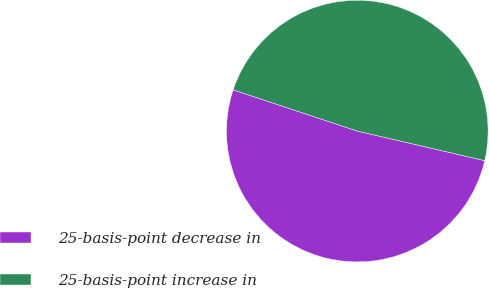<chart> <loc_0><loc_0><loc_500><loc_500><pie_chart><fcel>25-basis-point decrease in<fcel>25-basis-point increase in<nl><fcel>51.47%<fcel>48.53%<nl></chart> 